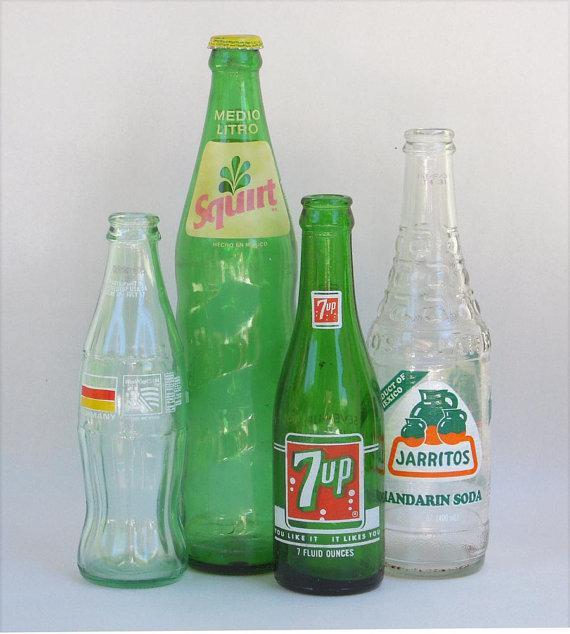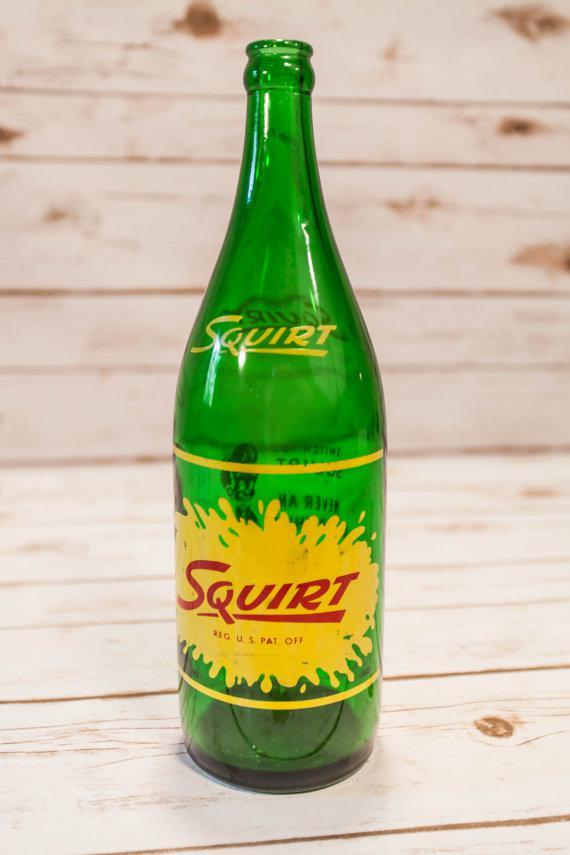The first image is the image on the left, the second image is the image on the right. Evaluate the accuracy of this statement regarding the images: "The left image contains exactly four glass bottles.". Is it true? Answer yes or no. Yes. The first image is the image on the left, the second image is the image on the right. Analyze the images presented: Is the assertion "Each image contains one green bottle, and at least one of the bottles pictured has diagonal ribs around its lower half." valid? Answer yes or no. No. 